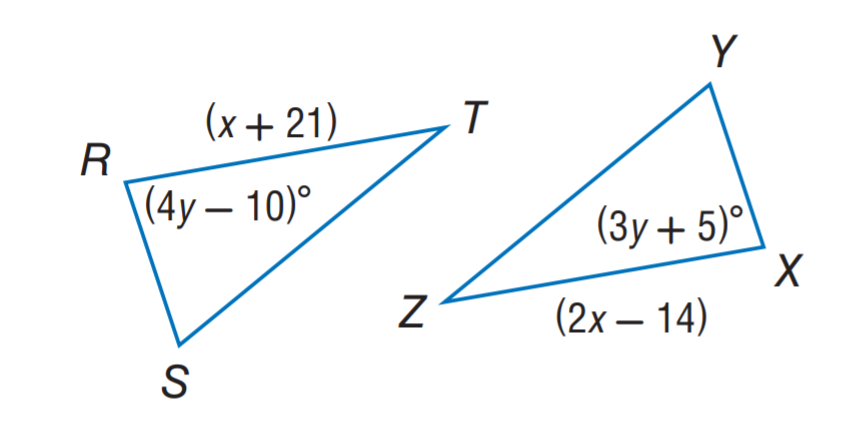Question: \triangle R S T \cong \triangle X Y Z. Find y.
Choices:
A. 5
B. 14
C. 15
D. 35
Answer with the letter. Answer: C Question: \triangle R S T \cong \triangle X Y Z. Find x.
Choices:
A. 10
B. 15
C. 21
D. 35
Answer with the letter. Answer: D 